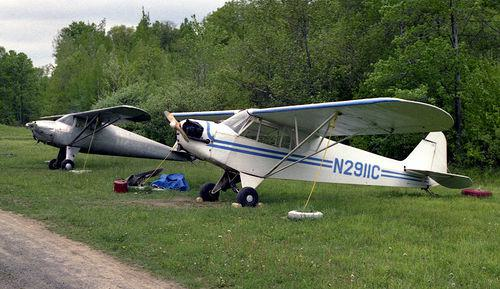How many aeroplanes would there be in the image if one additional aeroplane was added in the scene? If one more aeroplane were added to the two already present in the photo, there would be a total of three aeroplanes. 